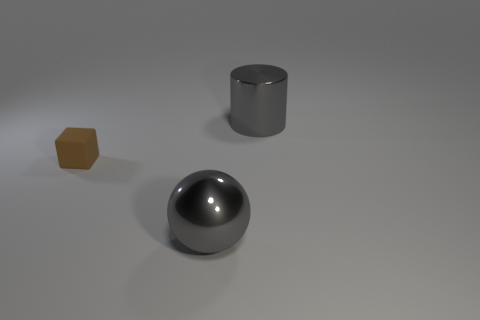There is a thing that is made of the same material as the gray sphere; what is its size?
Ensure brevity in your answer.  Large. How many things are either big objects that are behind the brown matte cube or objects behind the tiny block?
Make the answer very short. 1. Do the metal thing behind the gray sphere and the small object have the same size?
Your answer should be very brief. No. What is the color of the big object in front of the brown block?
Keep it short and to the point. Gray. There is a shiny object behind the big gray object in front of the tiny brown thing; how many gray metallic balls are on the right side of it?
Provide a short and direct response. 0. Are there any other things that have the same material as the tiny thing?
Provide a succinct answer. No. Are there fewer gray metal things left of the gray sphere than big red spheres?
Offer a terse response. No. Is the rubber cube the same color as the metal ball?
Provide a short and direct response. No. What number of big things have the same material as the large sphere?
Your response must be concise. 1. Are the big gray object that is to the left of the cylinder and the small brown object made of the same material?
Your response must be concise. No. 